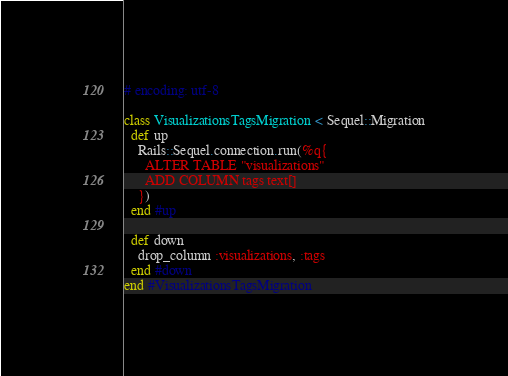Convert code to text. <code><loc_0><loc_0><loc_500><loc_500><_Ruby_># encoding: utf-8

class VisualizationsTagsMigration < Sequel::Migration
  def up
    Rails::Sequel.connection.run(%q{
      ALTER TABLE "visualizations"
      ADD COLUMN tags text[]
    })
  end #up
  
  def down
    drop_column :visualizations, :tags
  end #down
end #VisualizationsTagsMigration

</code> 